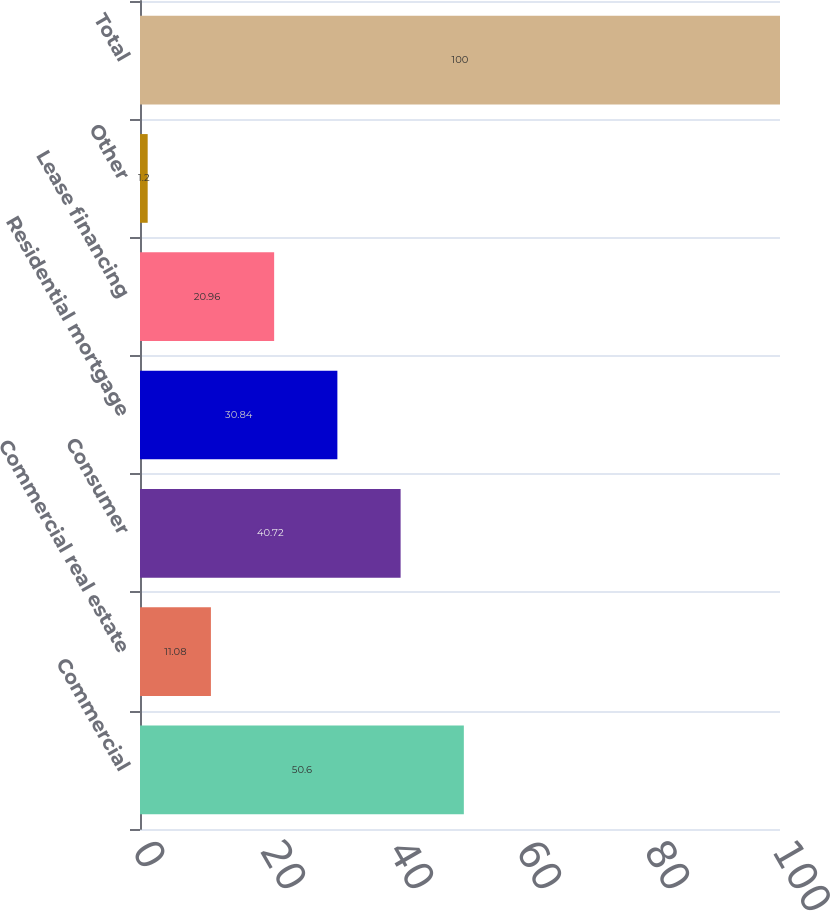Convert chart. <chart><loc_0><loc_0><loc_500><loc_500><bar_chart><fcel>Commercial<fcel>Commercial real estate<fcel>Consumer<fcel>Residential mortgage<fcel>Lease financing<fcel>Other<fcel>Total<nl><fcel>50.6<fcel>11.08<fcel>40.72<fcel>30.84<fcel>20.96<fcel>1.2<fcel>100<nl></chart> 